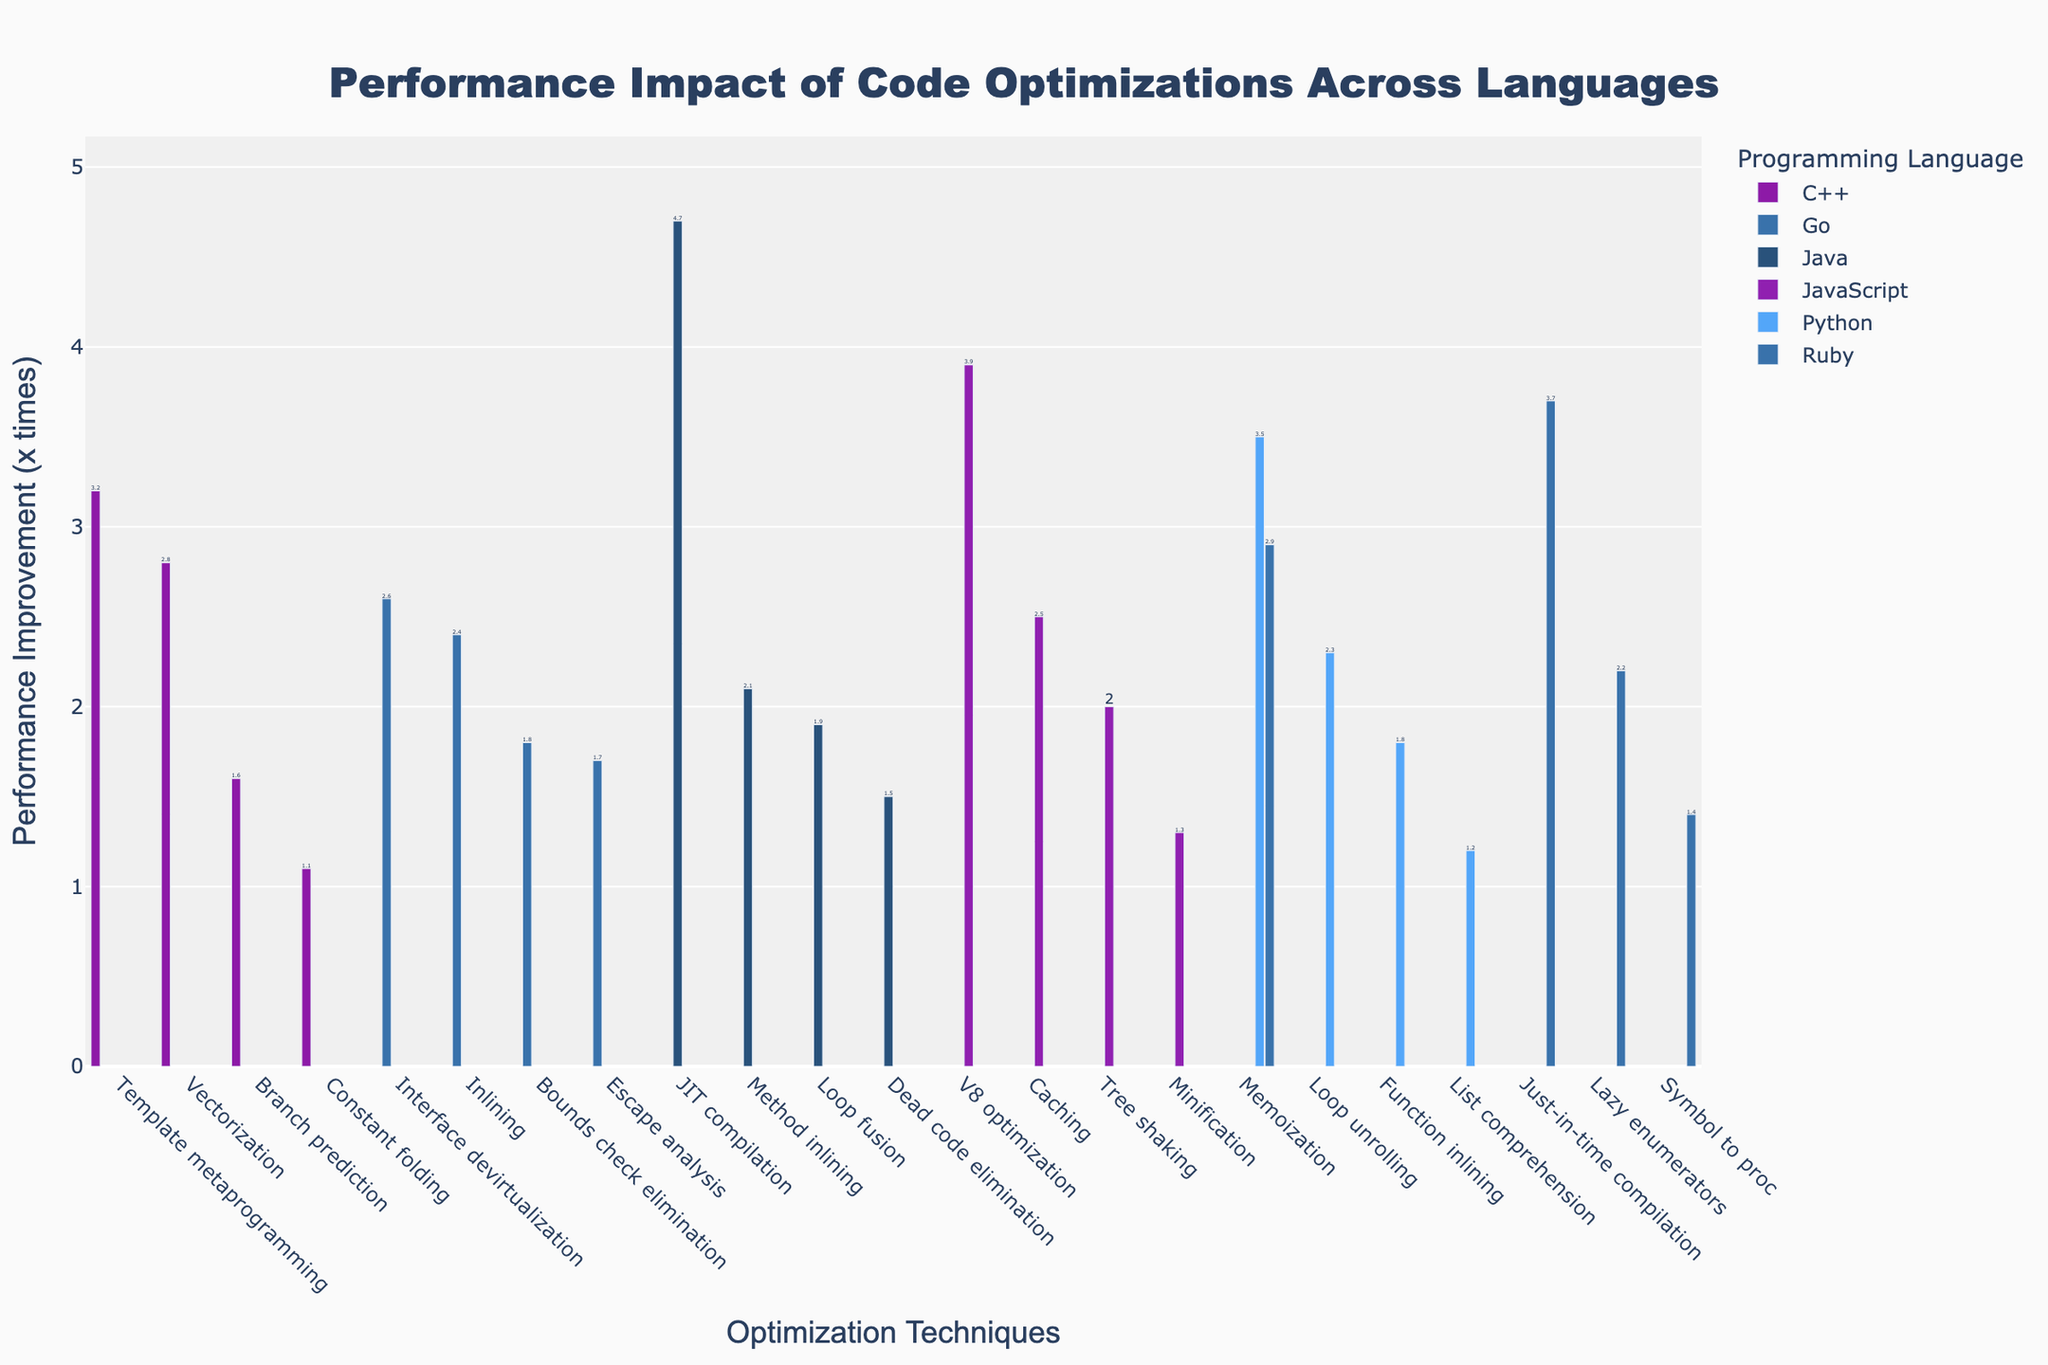What's the highest performance improvement technique for Python? Scan the bar for Python optimizations and pick the tallest. The highest bar is Memoization with a performance improvement of 3.5x.
Answer: Memoization How many optimization techniques are evaluated for JavaScript? Count the number of bars associated with JavaScript. There are four optimization techniques (V8 optimization, Minification, Tree shaking, Caching).
Answer: 4 Which language has the greatest performance improvement overall? Compare the tallest bars among all languages. The tallest bar is JIT compilation for Java with 4.7x.
Answer: Java Whose performance improvements does template metaprogramming in C++ compare to memoization in Ruby? Look at the bars for those specific optimizations. Template metaprogramming in C++ has an improvement of 3.2x, while memoization in Ruby has an improvement of 2.9x.
Answer: C++ is slightly better What's the combined performance improvement of List comprehension in Python and Symbol to proc in Ruby? Add the two values: List comprehension (1.2) and Symbol to proc (1.4). The combined performance improvement is 1.2 + 1.4 = 2.6x.
Answer: 2.6x Which optimization technique has the lowest performance improvement in Go? Identify the smallest bar for Go optimizations. The lowest is Escape analysis with 1.7x.
Answer: Escape analysis Which optimization in JavaScript has the second highest performance improvement? Look at the bars and rank them. The highest is V8 optimization (3.9), the second highest is Caching (2.5).
Answer: Caching Are the performance improvements of Inlining in Go and Lazy enumerators in Ruby equal or different? Compare the two value bars. Inlining in Go shows 2.4x and Lazy enumerators in Ruby shows 2.2x. They are different.
Answer: Different What is the average performance improvement across all optimizations in Java? Sum the performance improvements for Java (4.7, 1.5, 2.1, 1.9) and divide by the number of optimizations (4). The sum is 4.7 + 1.5 + 2.1 + 1.9 = 10.2, so the average is 10.2 / 4 = 2.55x.
Answer: 2.55x 